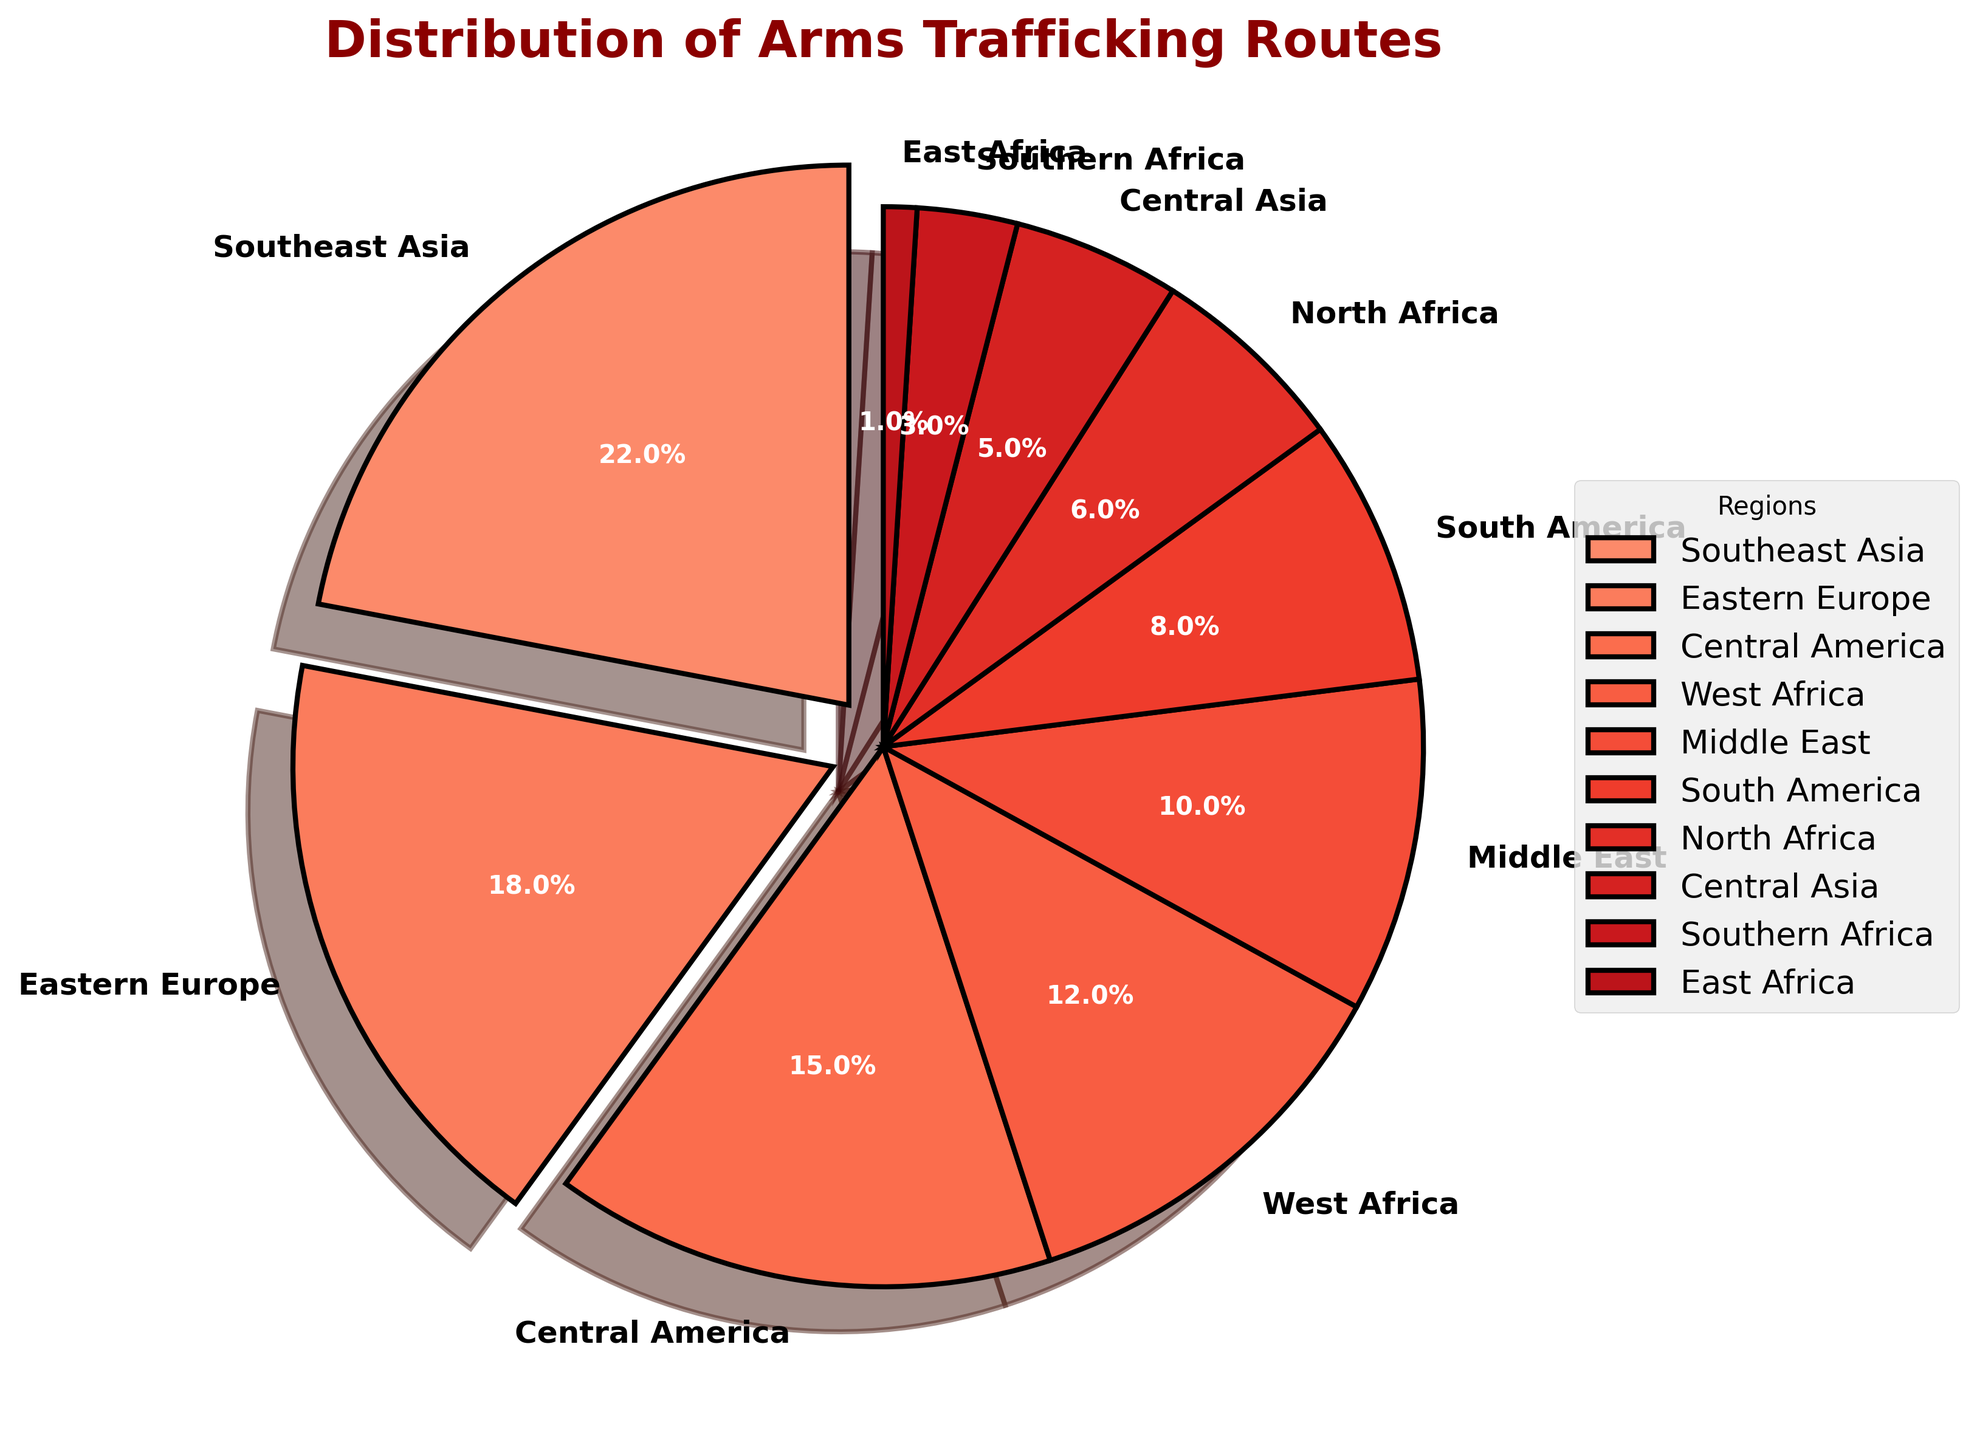Which region has the highest percentage of arms trafficking routes? By looking at the figure, the largest wedge in the pie chart represents Southeast Asia, and its percentage is labeled as 22%.
Answer: Southeast Asia What is the combined percentage of arms trafficking routes in Southeast Asia and Eastern Europe? To find the combined percentage, add the values for Southeast Asia and Eastern Europe: 22% + 18% = 40%.
Answer: 40% Which region has the smallest percentage of arms trafficking routes? The smallest wedge in the pie chart corresponds to East Africa, which is labeled as 1%.
Answer: East Africa What is the percentage difference between Central America and South America? The percentage for Central America is 15%, and for South America, it is 8%. The difference is 15% - 8% = 7%.
Answer: 7% Which regions have a percentage higher than 15%? By inspecting the wedges and their labels, Southeast Asia (22%) and Eastern Europe (18%) both have percentages higher than 15%.
Answer: Southeast Asia, Eastern Europe What is the total percentage of arms trafficking routes attributed to African regions? Sum the percentages for West Africa, North Africa, Southern Africa, and East Africa: 12% + 6% + 3% + 1% = 22%.
Answer: 22% Is the percentage of arms trafficking routes in the Middle East higher than that in North Africa? Comparing the percentages, the Middle East has 10%, while North Africa has 6%. Since 10% > 6%, the Middle East has a higher percentage.
Answer: Yes Which continent has the most regions featured in the pie chart, and how many? The continents and their regions are: Africa (West, North, South, East) - 4; Asia (Southeast, Central) - 2; Europe (Eastern) - 1; America (Central, South) - 2; Middle East - 1. Africa has the most regions.
Answer: Africa, 4 Calculate the sum of percentages for regions with less than 10%. The regions and their percentages below 10% are South America (8%), North Africa (6%), Central Asia (5%), Southern Africa (3%), East Africa (1%). Sum them up: 8% + 6% + 5% + 3% + 1% = 23%.
Answer: 23% What is the average percentage of arms trafficking routes for all regions depicted in the pie chart? There are 10 regions with percentages: 22, 18, 15, 12, 10, 8, 6, 5, 3, 1. Sum them up: 22 + 18 + 15 + 12 + 10 + 8 + 6 + 5 + 3 + 1 = 100. The average is 100/10 = 10%.
Answer: 10% 